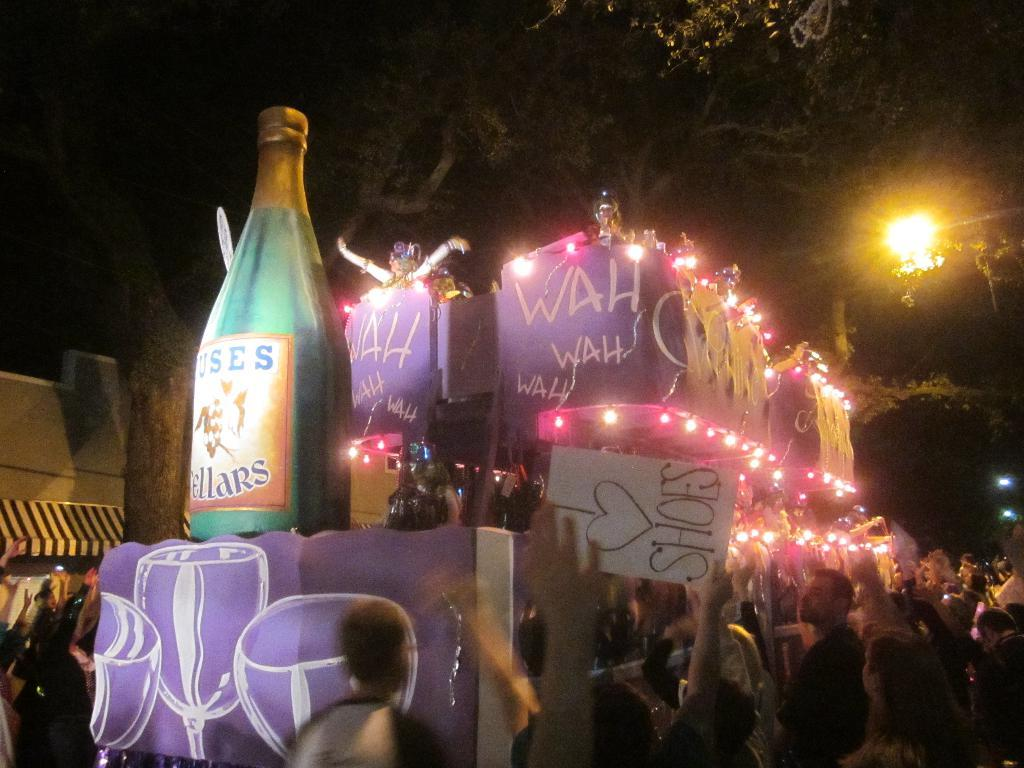<image>
Relay a brief, clear account of the picture shown. A person in a crowd holds a sign that reads I love Shoes! 